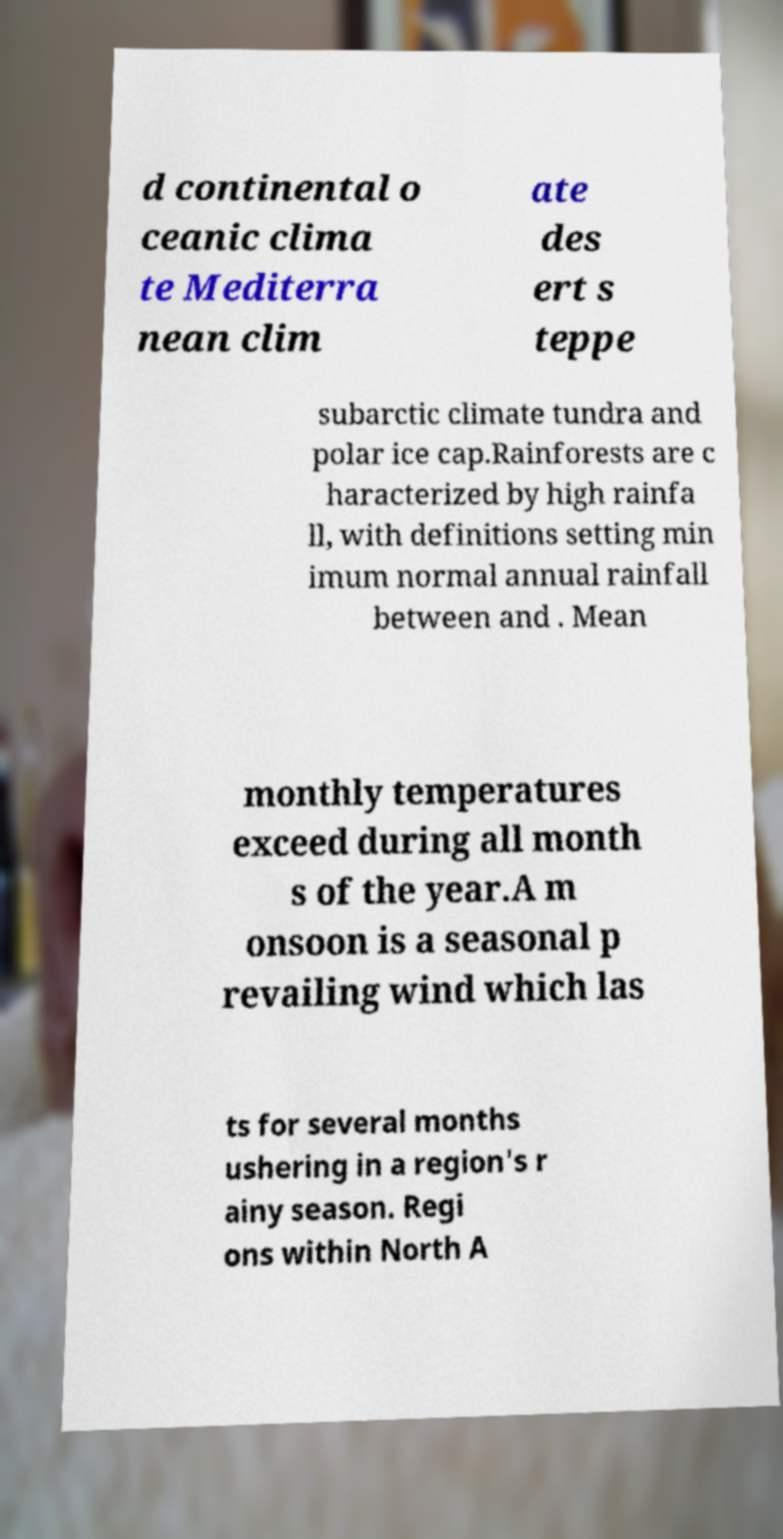There's text embedded in this image that I need extracted. Can you transcribe it verbatim? d continental o ceanic clima te Mediterra nean clim ate des ert s teppe subarctic climate tundra and polar ice cap.Rainforests are c haracterized by high rainfa ll, with definitions setting min imum normal annual rainfall between and . Mean monthly temperatures exceed during all month s of the year.A m onsoon is a seasonal p revailing wind which las ts for several months ushering in a region's r ainy season. Regi ons within North A 